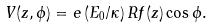Convert formula to latex. <formula><loc_0><loc_0><loc_500><loc_500>V ( z , \phi ) = e \, ( E _ { 0 } / \kappa ) \, R f ( z ) \cos \phi .</formula> 